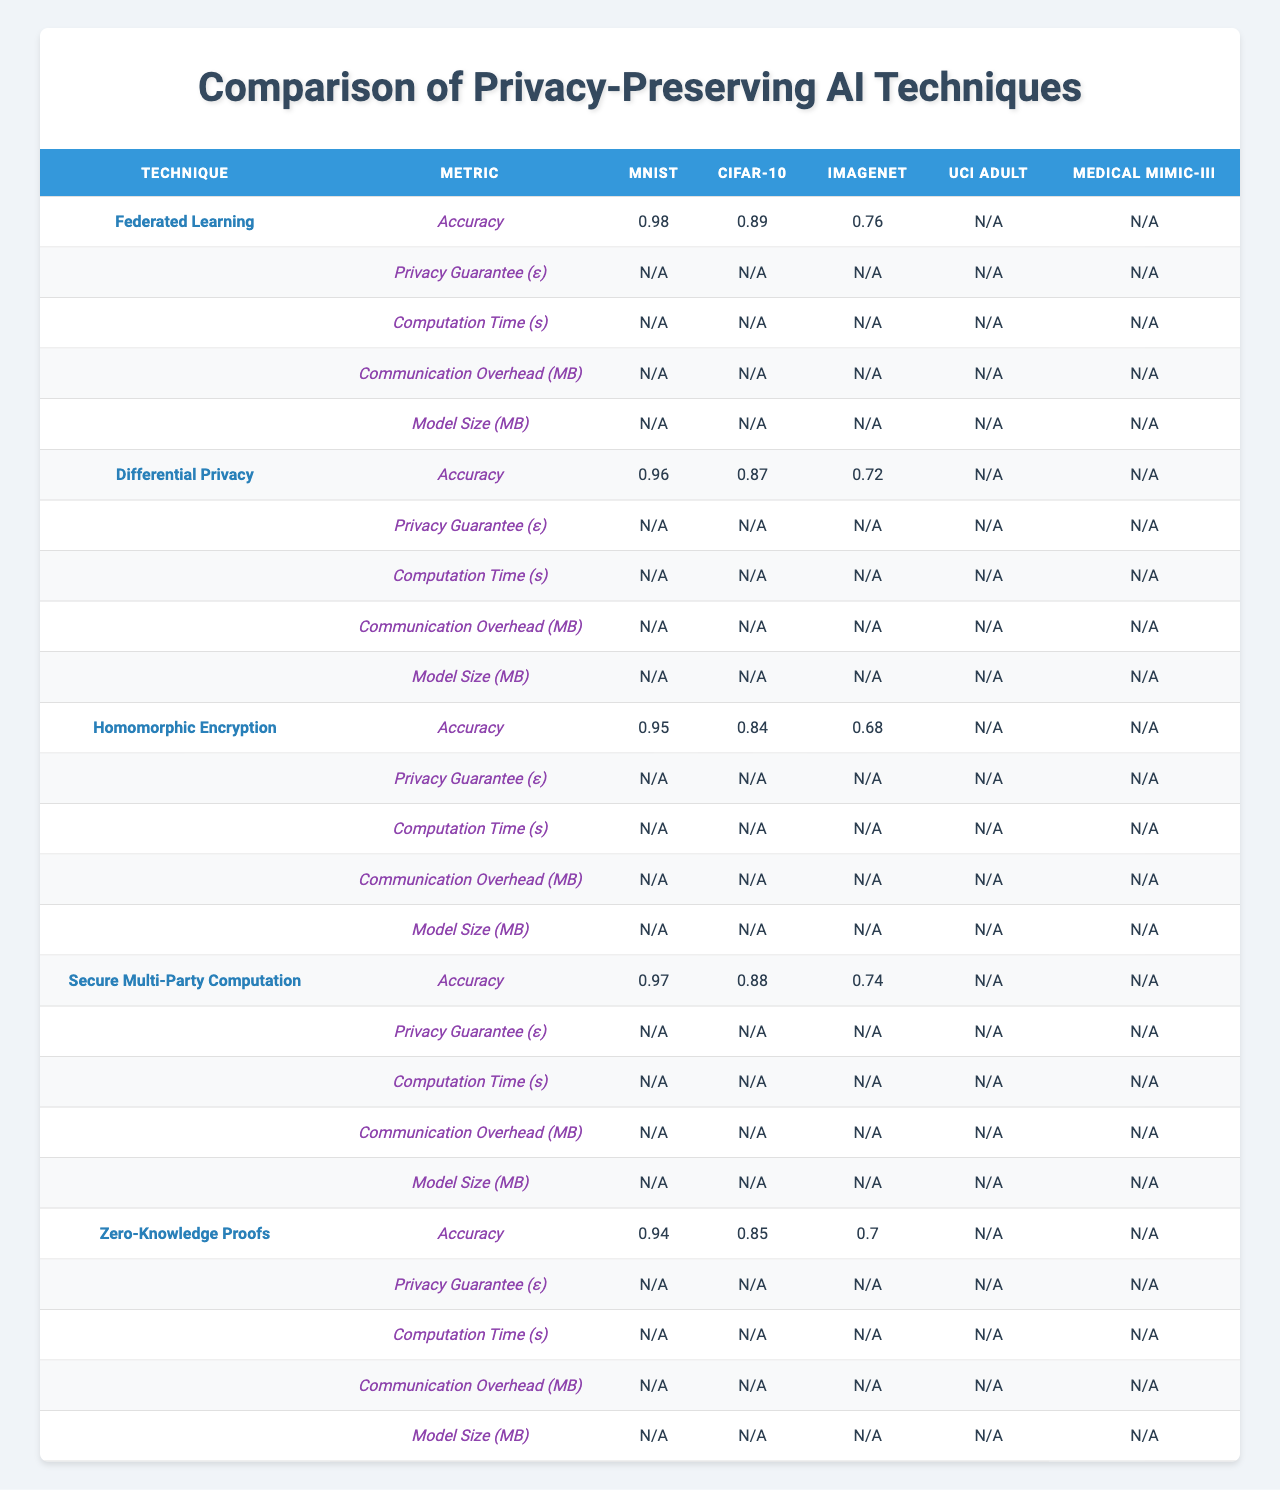What is the highest accuracy achieved by any technique on the MNIST dataset? The MNIST accuracy values are 0.98 for Federated Learning, 0.96 for Differential Privacy, 0.95 for Homomorphic Encryption, 0.97 for Secure Multi-Party Computation, and 0.94 for Zero-Knowledge Proofs. The highest value among these is 0.98.
Answer: 0.98 Which technique has the lowest privacy guarantee on the UCI Adult dataset? The UCI Adult privacy guarantees are 2.9 for Federated Learning, 1.5 for Differential Privacy, 0.4 for Homomorphic Encryption, 0.7 for Secure Multi-Party Computation, and 0.2 for Zero-Knowledge Proofs. The lowest value among these is 0.2.
Answer: 0.2 What is the average computation time for the CIFAR-10 dataset across all techniques? The computation times for CIFAR-10 are 450s (Federated Learning), 520s (Differential Privacy), 14400s (Homomorphic Encryption), 3600s (Secure Multi-Party Computation), and 7200s (Zero-Knowledge Proofs). Adding these values gives 18330s, and dividing by 5 results in an average of 3666s.
Answer: 3666 Is the communication overhead for Secure Multi-Party Computation on the Medical MIMIC-III dataset greater than 600 MB? The communication overhead for Secure Multi-Party Computation on the Medical MIMIC-III dataset is 680.2 MB, which is greater than 600 MB, making this statement true.
Answer: Yes Which technique has the best overall accuracy across all datasets? To determine the overall accuracy, we average the accuracies across all datasets for each technique: 0.98 (FL), 0.96 (DP), 0.95 (HE), 0.97 (MPC), and 0.94 (ZKP) for MNIST; 0.89 (FL), 0.87 (DP), 0.84 (HE), 0.88 (MPC), 0.85 (ZKP) for CIFAR-10; 0.76 (FL), 0.72 (DP), 0.68 (HE), 0.74 (MPC), 0.70 (ZKP) for ImageNet; 0.85 (FL), 0.83 (DP), 0.81 (HE), 0.84 (MPC), 0.82 (ZKP) for UCI Adult; and 0.91 (FL), 0.89 (DP), 0.87 (HE), 0.90 (MPC), 0.88 (ZKP) for MIMIC-III. The averages yield 0.92 for Federated Learning, 0.91 for Differential Privacy, 0.82 for Homomorphic Encryption, 0.91 for Secure Multi-Party Computation, and 0.86 for Zero-Knowledge Proofs. Therefore, Federated Learning and Differential Privacy are tied for the best overall accuracy at 0.91.
Answer: Federated Learning and Differential Privacy What is the computation time for Differential Privacy on the Medical MIMIC-III dataset compared to that of other techniques? The computation time for Differential Privacy on the Medical MIMIC-III dataset is 1050s, while the other techniques have times of 900s (Federated Learning), 28800s (Homomorphic Encryption), 7200s (Secure Multi-Party Computation), and 14400s (Zero-Knowledge Proofs). Thus, Differential Privacy has a relatively shorter computation time compared to Homomorphic Encryption and Zero-Knowledge Proofs but is longer than Federated Learning and Secure Multi-Party Computation.
Answer: 1050s Which technique shows the most significant reduction in privacy guarantee when comparing the MNIST to ImageNet datasets? Comparing the privacy guarantees: Federated Learning (4.2 to 5.1 increasing as privacy decreases by 0.9), Differential Privacy (1.8 to 2.7 decreasing by 0.9), Homomorphic Encryption (0.5 to 0.9 decreasing by 0.4), Secure Multi-Party Computation (0.8 to 1.5 decreasing by 0.7), and Zero-Knowledge Proofs (0.3 to 0.7 decreasing by 0.4). Differential Privacy shows the most significant decrease in privacy guarantee with a change of 0.9.
Answer: Differential Privacy 